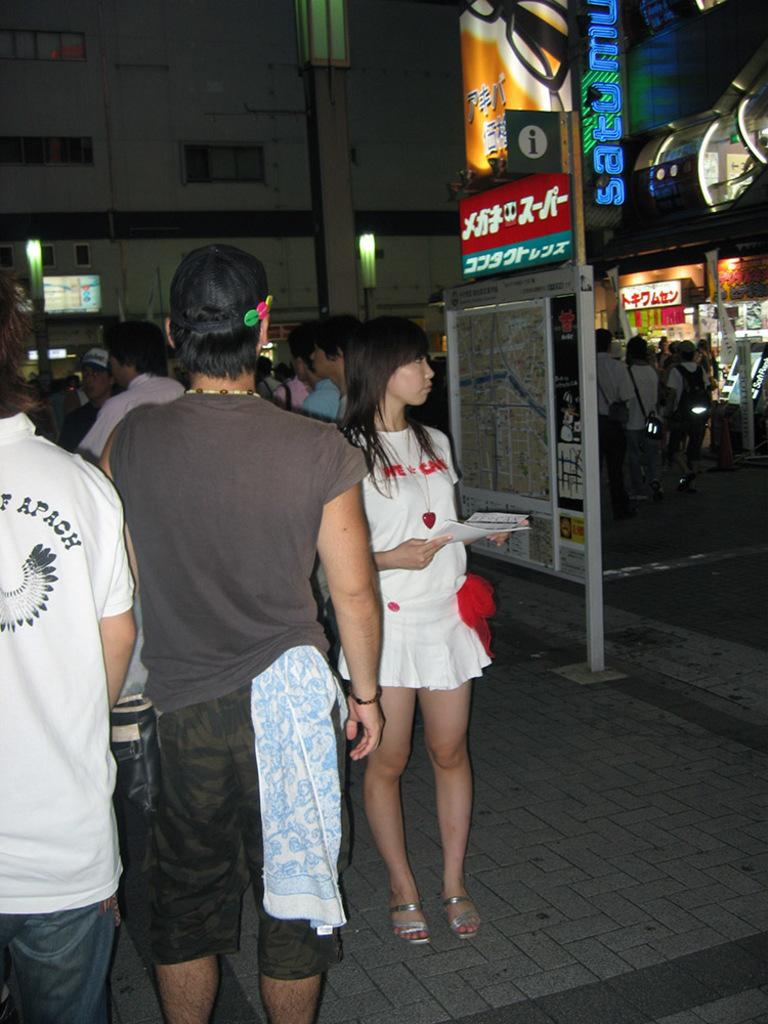How many people are present in the image? There are many people in the image. What can be seen on the onboard? There is something on the onboard, but the specific item is not mentioned in the facts. What type of signage is present in the image? There are name boards in the image. What can be seen in the background of the image? There are lights visible in the background. Are there any additional light sources in the image? Yes, there are additional lights in the image. What type of cherries are being served in the juice in the image? There is no mention of cherries or juice in the image, so this question cannot be answered definitively. 